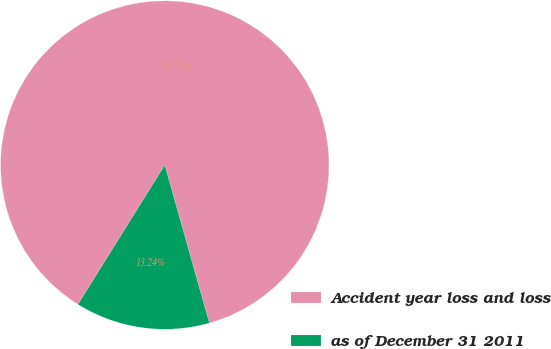<chart> <loc_0><loc_0><loc_500><loc_500><pie_chart><fcel>Accident year loss and loss<fcel>as of December 31 2011<nl><fcel>86.76%<fcel>13.24%<nl></chart> 